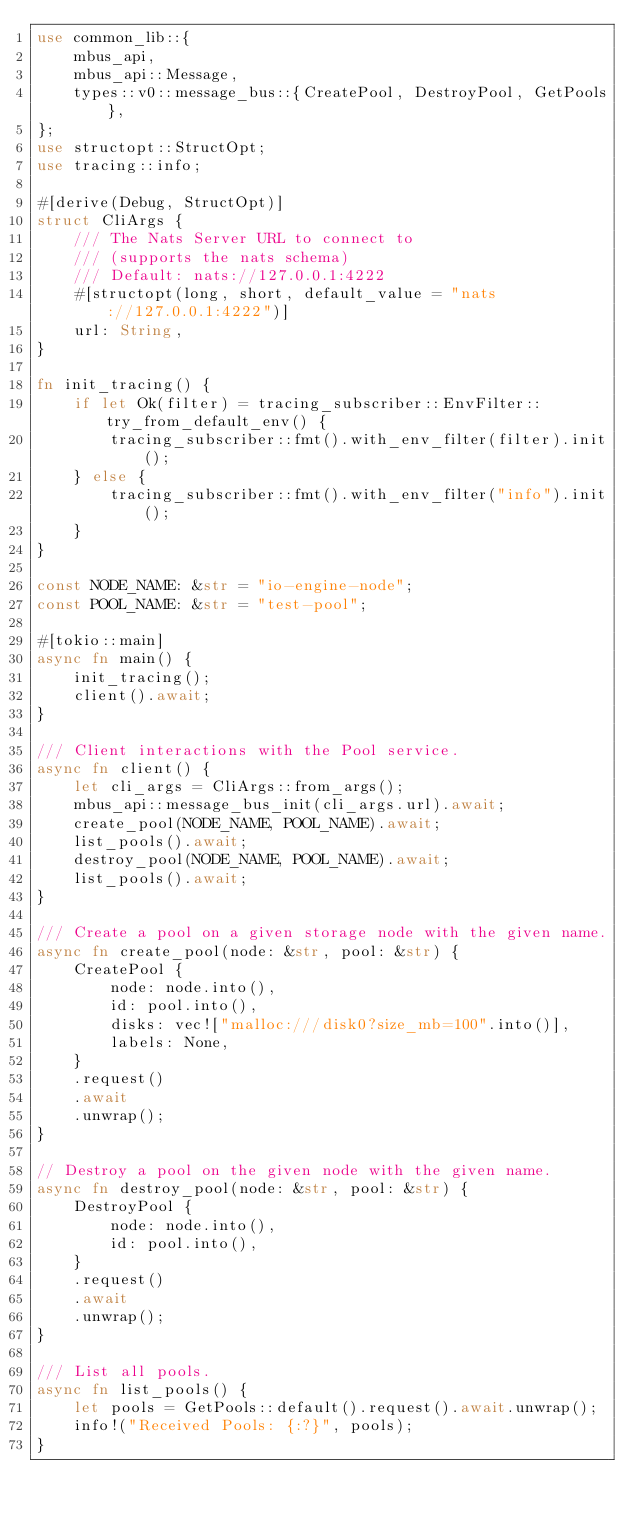Convert code to text. <code><loc_0><loc_0><loc_500><loc_500><_Rust_>use common_lib::{
    mbus_api,
    mbus_api::Message,
    types::v0::message_bus::{CreatePool, DestroyPool, GetPools},
};
use structopt::StructOpt;
use tracing::info;

#[derive(Debug, StructOpt)]
struct CliArgs {
    /// The Nats Server URL to connect to
    /// (supports the nats schema)
    /// Default: nats://127.0.0.1:4222
    #[structopt(long, short, default_value = "nats://127.0.0.1:4222")]
    url: String,
}

fn init_tracing() {
    if let Ok(filter) = tracing_subscriber::EnvFilter::try_from_default_env() {
        tracing_subscriber::fmt().with_env_filter(filter).init();
    } else {
        tracing_subscriber::fmt().with_env_filter("info").init();
    }
}

const NODE_NAME: &str = "io-engine-node";
const POOL_NAME: &str = "test-pool";

#[tokio::main]
async fn main() {
    init_tracing();
    client().await;
}

/// Client interactions with the Pool service.
async fn client() {
    let cli_args = CliArgs::from_args();
    mbus_api::message_bus_init(cli_args.url).await;
    create_pool(NODE_NAME, POOL_NAME).await;
    list_pools().await;
    destroy_pool(NODE_NAME, POOL_NAME).await;
    list_pools().await;
}

/// Create a pool on a given storage node with the given name.
async fn create_pool(node: &str, pool: &str) {
    CreatePool {
        node: node.into(),
        id: pool.into(),
        disks: vec!["malloc:///disk0?size_mb=100".into()],
        labels: None,
    }
    .request()
    .await
    .unwrap();
}

// Destroy a pool on the given node with the given name.
async fn destroy_pool(node: &str, pool: &str) {
    DestroyPool {
        node: node.into(),
        id: pool.into(),
    }
    .request()
    .await
    .unwrap();
}

/// List all pools.
async fn list_pools() {
    let pools = GetPools::default().request().await.unwrap();
    info!("Received Pools: {:?}", pools);
}
</code> 